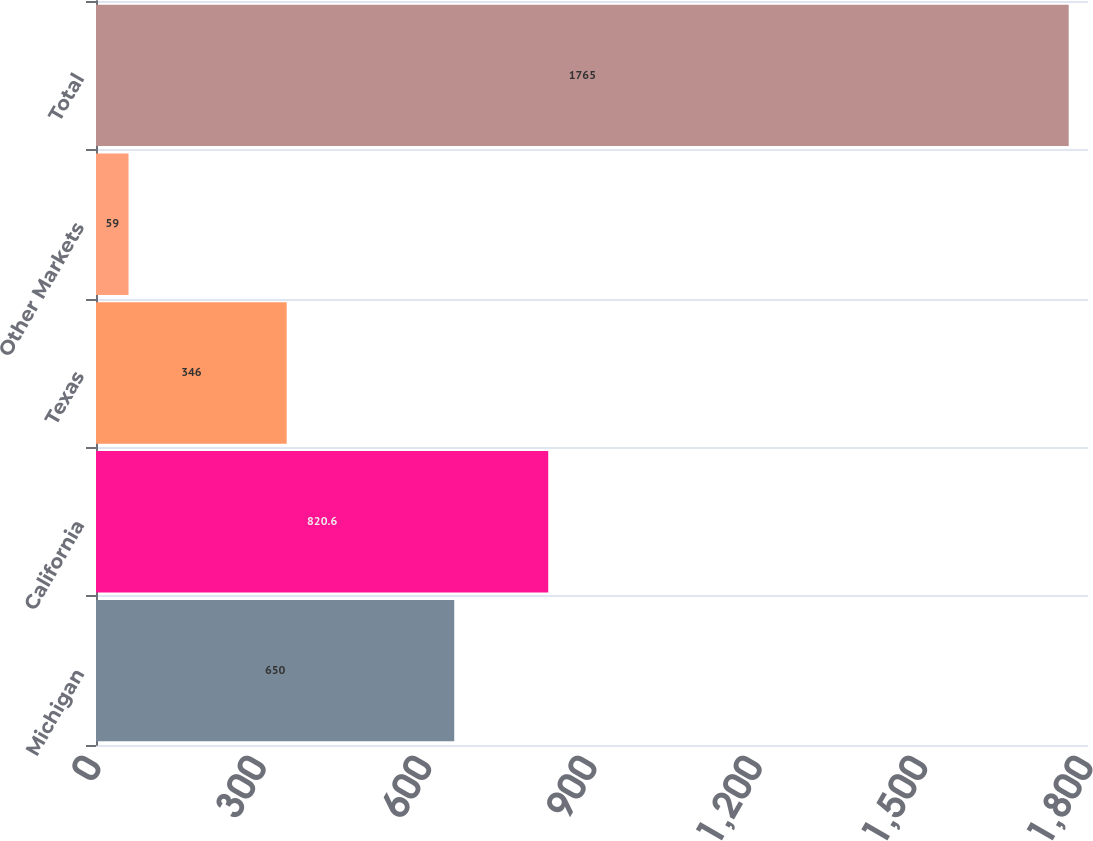Convert chart to OTSL. <chart><loc_0><loc_0><loc_500><loc_500><bar_chart><fcel>Michigan<fcel>California<fcel>Texas<fcel>Other Markets<fcel>Total<nl><fcel>650<fcel>820.6<fcel>346<fcel>59<fcel>1765<nl></chart> 